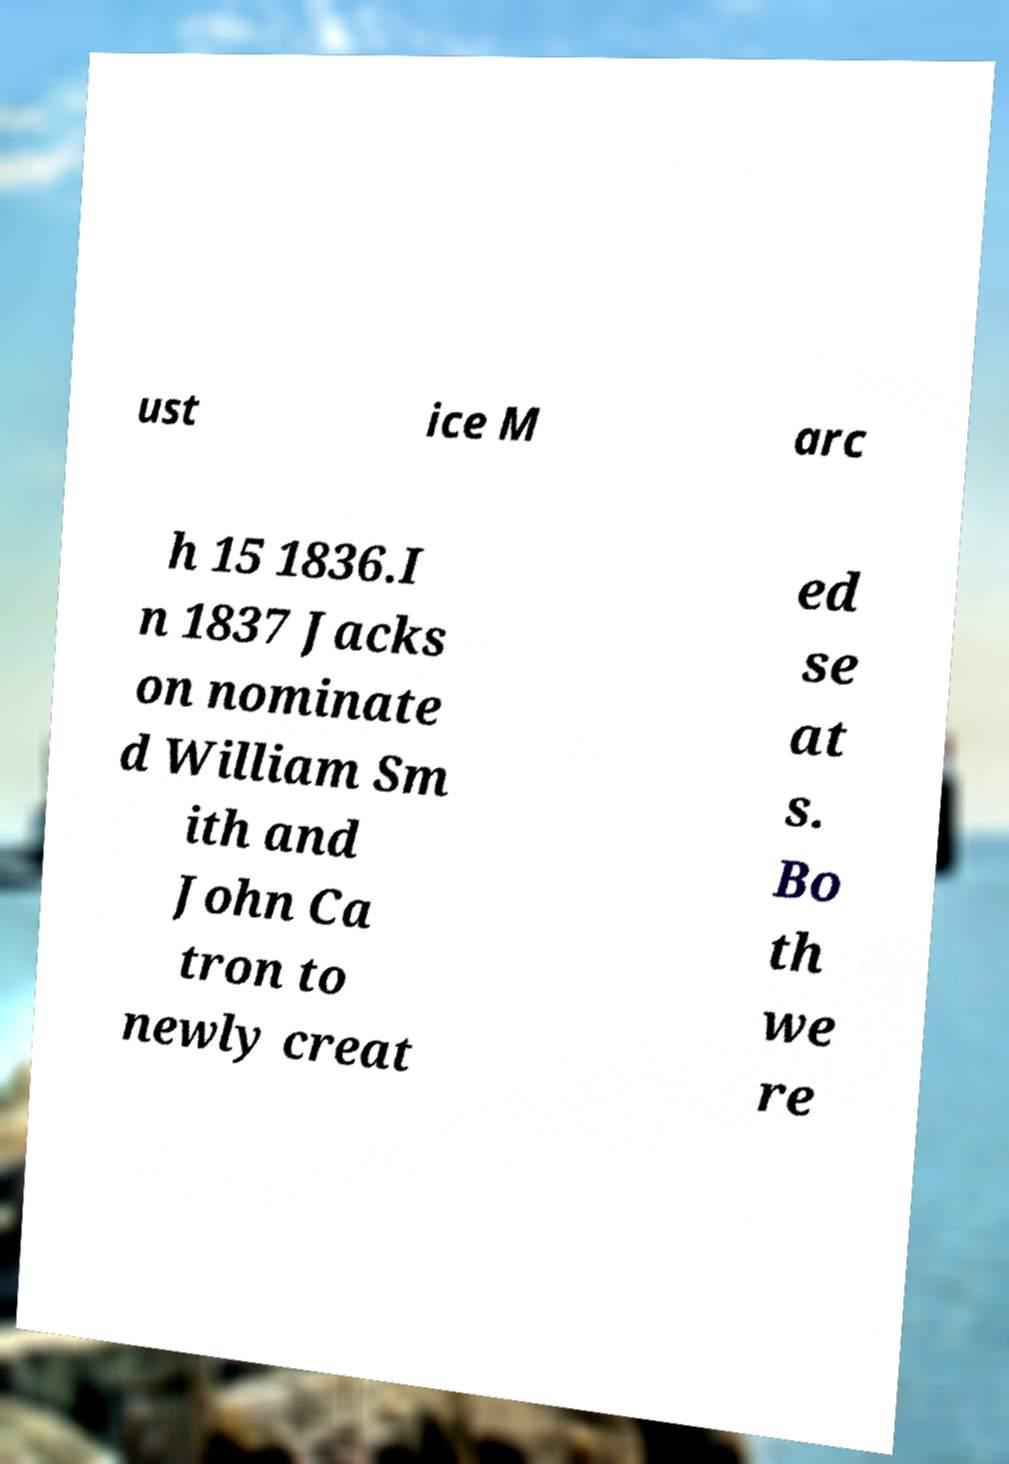Can you accurately transcribe the text from the provided image for me? ust ice M arc h 15 1836.I n 1837 Jacks on nominate d William Sm ith and John Ca tron to newly creat ed se at s. Bo th we re 